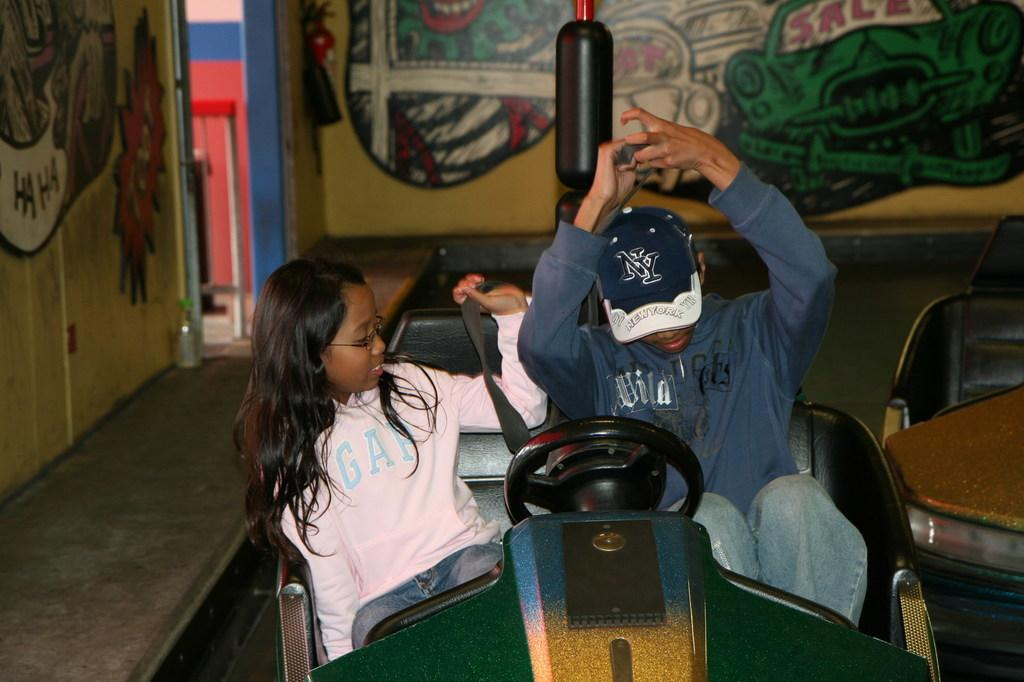<image>
Provide a brief description of the given image. couple in a bumper car, she is wearing a gap sweatshirt and he has a new york cap on 